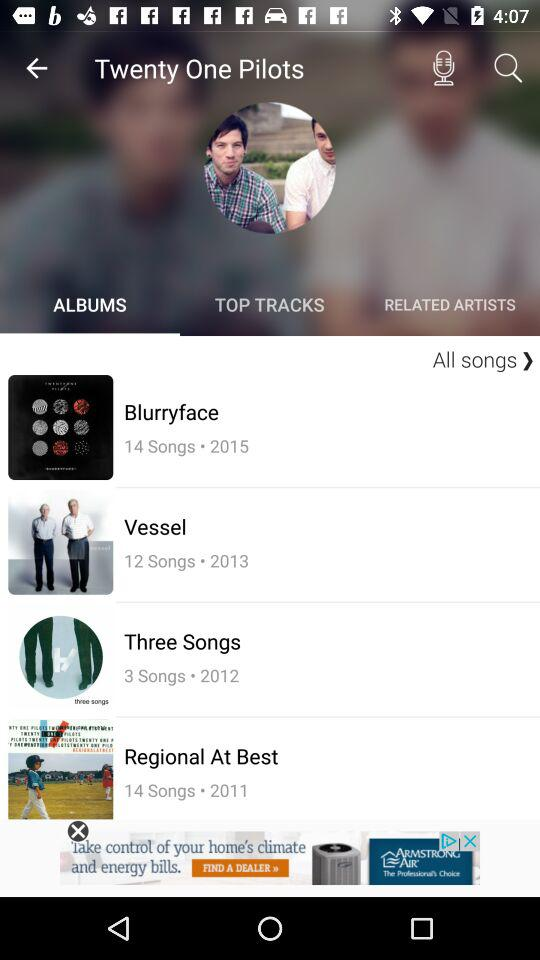Which tab is open? The open tab is "ALBUMS". 